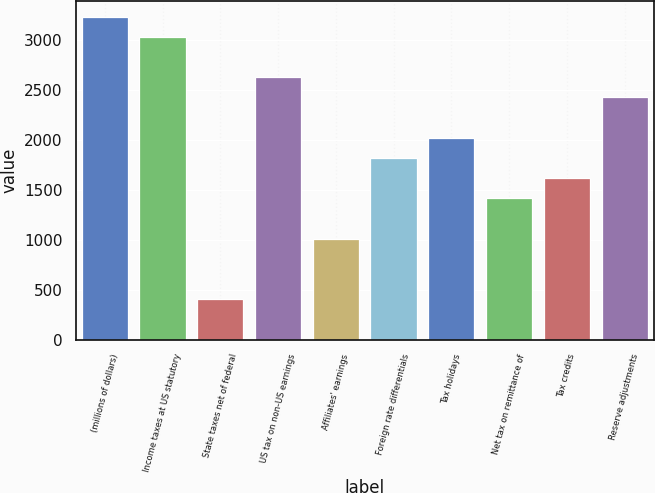<chart> <loc_0><loc_0><loc_500><loc_500><bar_chart><fcel>(millions of dollars)<fcel>Income taxes at US statutory<fcel>State taxes net of federal<fcel>US tax on non-US earnings<fcel>Affiliates' earnings<fcel>Foreign rate differentials<fcel>Tax holidays<fcel>Net tax on remittance of<fcel>Tax credits<fcel>Reserve adjustments<nl><fcel>3228.74<fcel>3026.95<fcel>403.68<fcel>2623.37<fcel>1009.05<fcel>1816.21<fcel>2018<fcel>1412.63<fcel>1614.42<fcel>2421.58<nl></chart> 